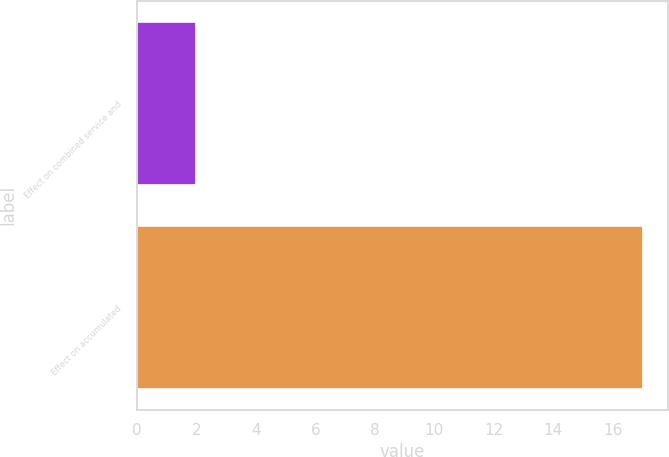Convert chart to OTSL. <chart><loc_0><loc_0><loc_500><loc_500><bar_chart><fcel>Effect on combined service and<fcel>Effect on accumulated<nl><fcel>2<fcel>17<nl></chart> 